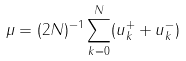<formula> <loc_0><loc_0><loc_500><loc_500>\mu = ( 2 N ) ^ { - 1 } \sum _ { k = 0 } ^ { N } ( u _ { k } ^ { + } + u _ { k } ^ { - } )</formula> 